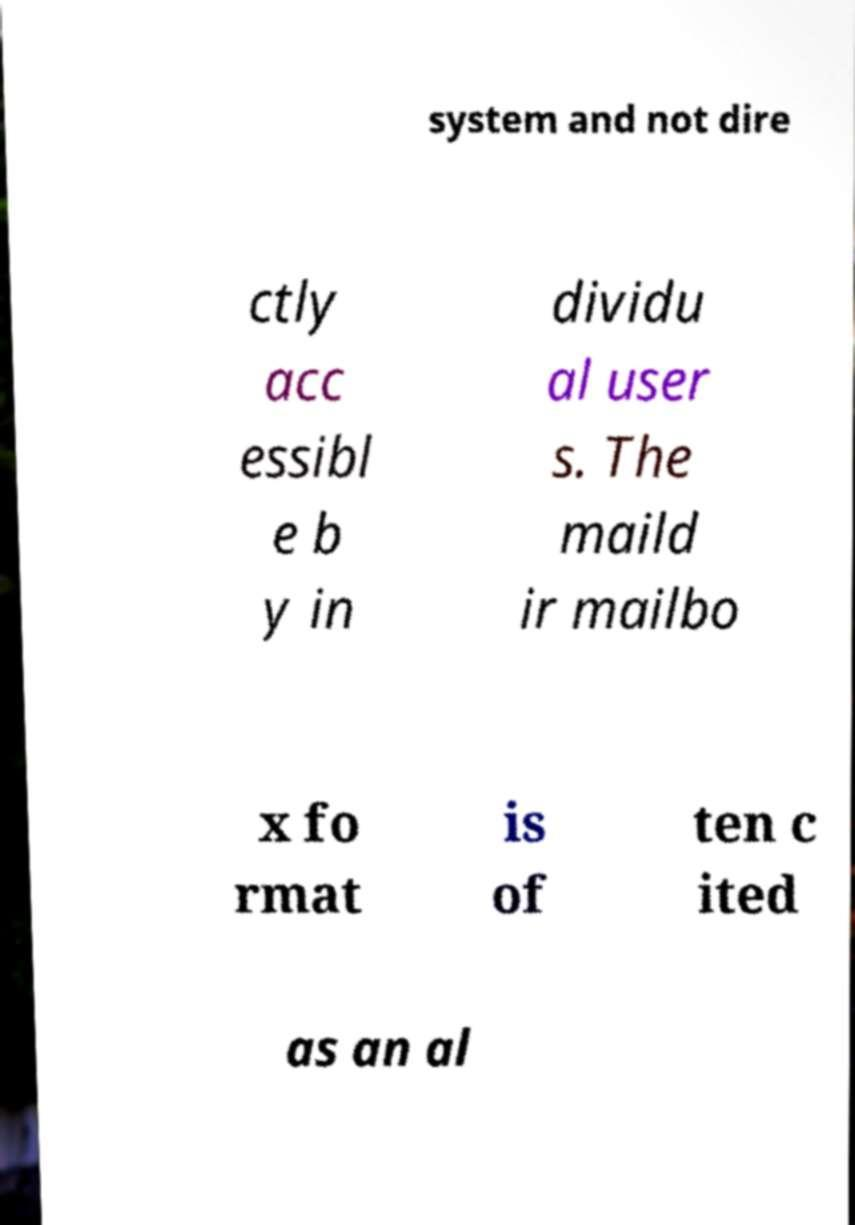Please identify and transcribe the text found in this image. system and not dire ctly acc essibl e b y in dividu al user s. The maild ir mailbo x fo rmat is of ten c ited as an al 